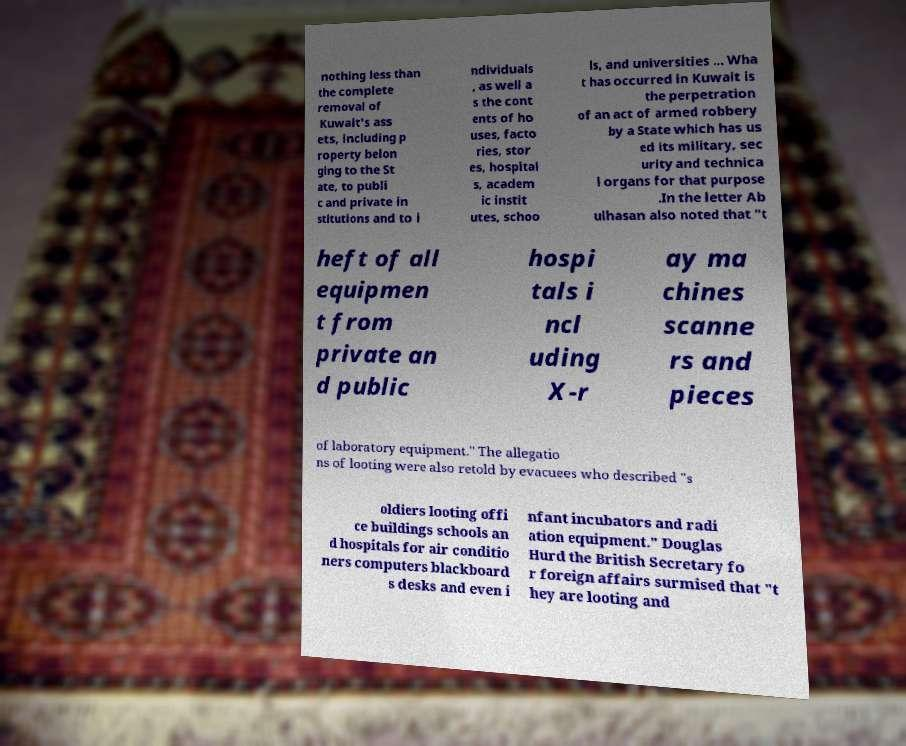There's text embedded in this image that I need extracted. Can you transcribe it verbatim? nothing less than the complete removal of Kuwait's ass ets, including p roperty belon ging to the St ate, to publi c and private in stitutions and to i ndividuals , as well a s the cont ents of ho uses, facto ries, stor es, hospital s, academ ic instit utes, schoo ls, and universities ... Wha t has occurred in Kuwait is the perpetration of an act of armed robbery by a State which has us ed its military, sec urity and technica l organs for that purpose .In the letter Ab ulhasan also noted that "t heft of all equipmen t from private an d public hospi tals i ncl uding X-r ay ma chines scanne rs and pieces of laboratory equipment." The allegatio ns of looting were also retold by evacuees who described "s oldiers looting offi ce buildings schools an d hospitals for air conditio ners computers blackboard s desks and even i nfant incubators and radi ation equipment." Douglas Hurd the British Secretary fo r foreign affairs surmised that "t hey are looting and 